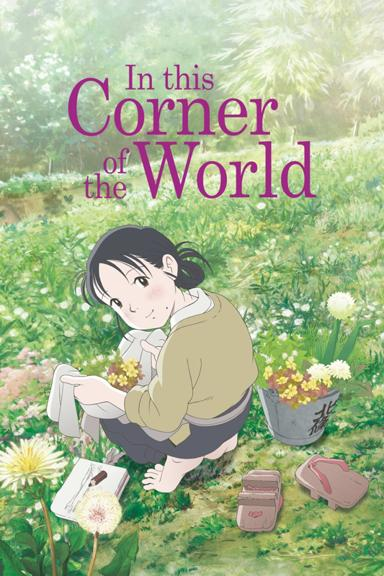What time of day does it appear to be in the image? It seems to be late morning or early afternoon, as indicated by the bright sunlight and the shadows being moderately short, suggesting the sun is high in the sky but not yet at its peak. 